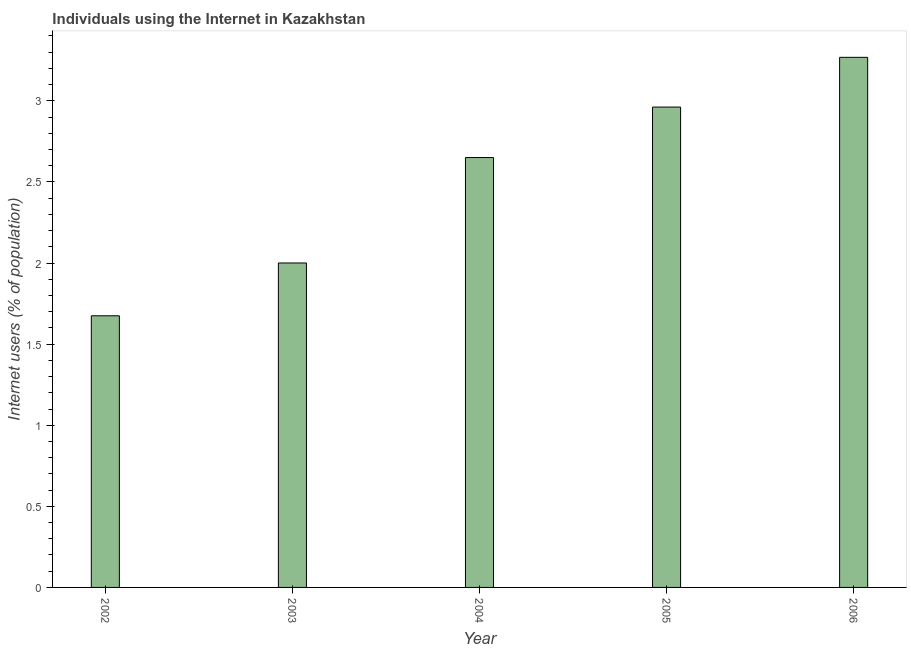Does the graph contain any zero values?
Your answer should be compact. No. Does the graph contain grids?
Your response must be concise. No. What is the title of the graph?
Your answer should be very brief. Individuals using the Internet in Kazakhstan. What is the label or title of the X-axis?
Provide a short and direct response. Year. What is the label or title of the Y-axis?
Your answer should be compact. Internet users (% of population). What is the number of internet users in 2005?
Give a very brief answer. 2.96. Across all years, what is the maximum number of internet users?
Provide a succinct answer. 3.27. Across all years, what is the minimum number of internet users?
Give a very brief answer. 1.67. What is the sum of the number of internet users?
Provide a short and direct response. 12.56. What is the difference between the number of internet users in 2002 and 2004?
Provide a succinct answer. -0.98. What is the average number of internet users per year?
Keep it short and to the point. 2.51. What is the median number of internet users?
Keep it short and to the point. 2.65. In how many years, is the number of internet users greater than 0.3 %?
Your answer should be very brief. 5. What is the ratio of the number of internet users in 2003 to that in 2006?
Your response must be concise. 0.61. Is the number of internet users in 2002 less than that in 2003?
Make the answer very short. Yes. Is the difference between the number of internet users in 2002 and 2005 greater than the difference between any two years?
Your answer should be very brief. No. What is the difference between the highest and the second highest number of internet users?
Provide a short and direct response. 0.31. What is the difference between the highest and the lowest number of internet users?
Your answer should be very brief. 1.59. How many bars are there?
Your answer should be very brief. 5. How many years are there in the graph?
Offer a terse response. 5. What is the difference between two consecutive major ticks on the Y-axis?
Ensure brevity in your answer.  0.5. Are the values on the major ticks of Y-axis written in scientific E-notation?
Your response must be concise. No. What is the Internet users (% of population) in 2002?
Give a very brief answer. 1.67. What is the Internet users (% of population) in 2003?
Offer a terse response. 2. What is the Internet users (% of population) of 2004?
Ensure brevity in your answer.  2.65. What is the Internet users (% of population) in 2005?
Provide a succinct answer. 2.96. What is the Internet users (% of population) of 2006?
Ensure brevity in your answer.  3.27. What is the difference between the Internet users (% of population) in 2002 and 2003?
Your answer should be compact. -0.33. What is the difference between the Internet users (% of population) in 2002 and 2004?
Your answer should be compact. -0.98. What is the difference between the Internet users (% of population) in 2002 and 2005?
Offer a very short reply. -1.29. What is the difference between the Internet users (% of population) in 2002 and 2006?
Offer a very short reply. -1.59. What is the difference between the Internet users (% of population) in 2003 and 2004?
Ensure brevity in your answer.  -0.65. What is the difference between the Internet users (% of population) in 2003 and 2005?
Your response must be concise. -0.96. What is the difference between the Internet users (% of population) in 2003 and 2006?
Offer a very short reply. -1.27. What is the difference between the Internet users (% of population) in 2004 and 2005?
Keep it short and to the point. -0.31. What is the difference between the Internet users (% of population) in 2004 and 2006?
Keep it short and to the point. -0.62. What is the difference between the Internet users (% of population) in 2005 and 2006?
Give a very brief answer. -0.31. What is the ratio of the Internet users (% of population) in 2002 to that in 2003?
Offer a terse response. 0.84. What is the ratio of the Internet users (% of population) in 2002 to that in 2004?
Your answer should be very brief. 0.63. What is the ratio of the Internet users (% of population) in 2002 to that in 2005?
Offer a very short reply. 0.56. What is the ratio of the Internet users (% of population) in 2002 to that in 2006?
Provide a succinct answer. 0.51. What is the ratio of the Internet users (% of population) in 2003 to that in 2004?
Give a very brief answer. 0.76. What is the ratio of the Internet users (% of population) in 2003 to that in 2005?
Give a very brief answer. 0.68. What is the ratio of the Internet users (% of population) in 2003 to that in 2006?
Your answer should be compact. 0.61. What is the ratio of the Internet users (% of population) in 2004 to that in 2005?
Ensure brevity in your answer.  0.9. What is the ratio of the Internet users (% of population) in 2004 to that in 2006?
Offer a very short reply. 0.81. What is the ratio of the Internet users (% of population) in 2005 to that in 2006?
Provide a succinct answer. 0.91. 